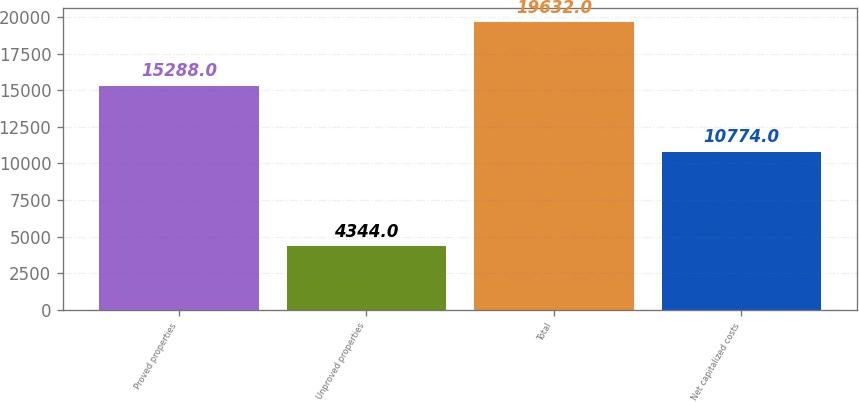Convert chart. <chart><loc_0><loc_0><loc_500><loc_500><bar_chart><fcel>Proved properties<fcel>Unproved properties<fcel>Total<fcel>Net capitalized costs<nl><fcel>15288<fcel>4344<fcel>19632<fcel>10774<nl></chart> 